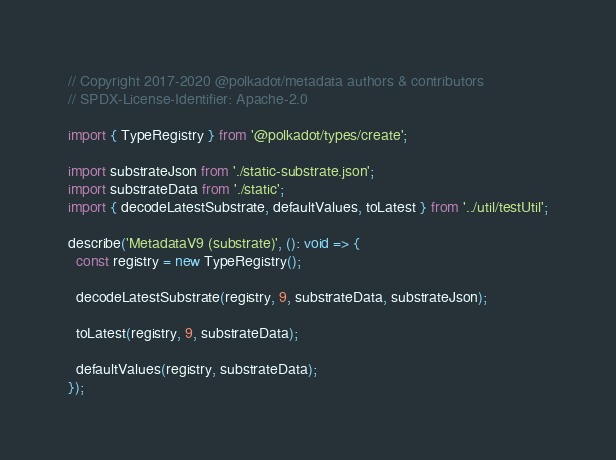<code> <loc_0><loc_0><loc_500><loc_500><_TypeScript_>// Copyright 2017-2020 @polkadot/metadata authors & contributors
// SPDX-License-Identifier: Apache-2.0

import { TypeRegistry } from '@polkadot/types/create';

import substrateJson from './static-substrate.json';
import substrateData from './static';
import { decodeLatestSubstrate, defaultValues, toLatest } from '../util/testUtil';

describe('MetadataV9 (substrate)', (): void => {
  const registry = new TypeRegistry();

  decodeLatestSubstrate(registry, 9, substrateData, substrateJson);

  toLatest(registry, 9, substrateData);

  defaultValues(registry, substrateData);
});
</code> 